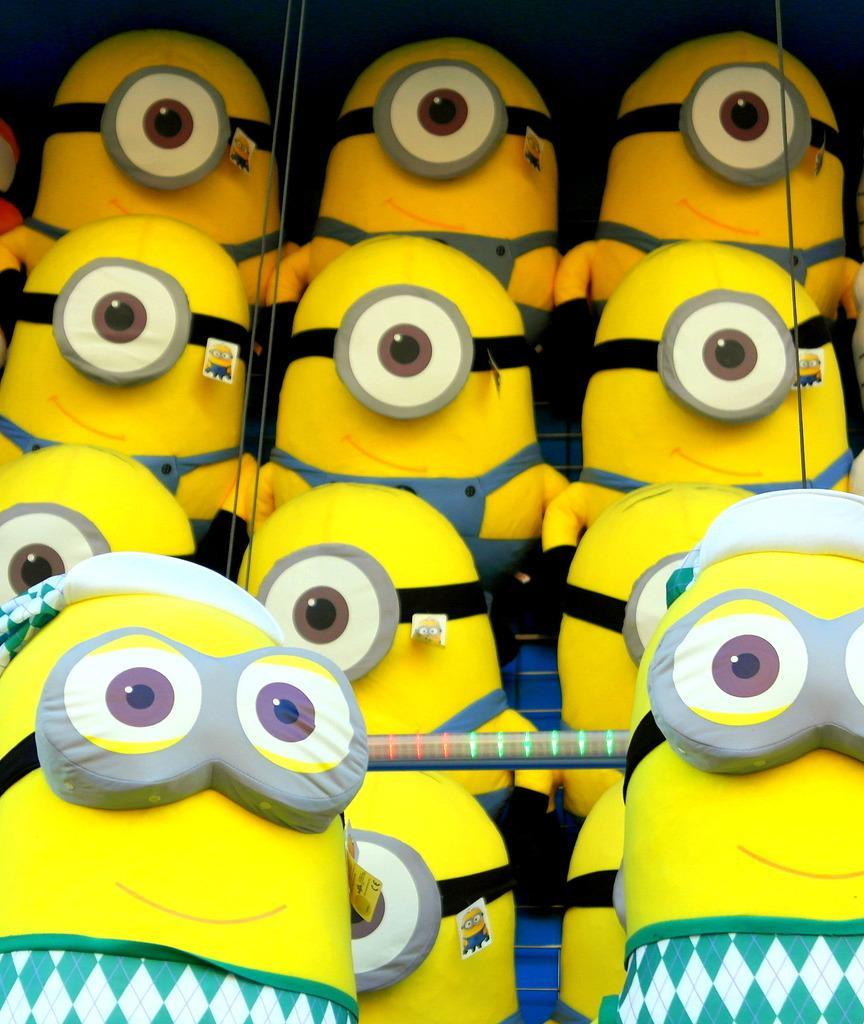Describe this image in one or two sentences. In this image, we can see some minions. 